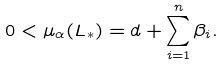Convert formula to latex. <formula><loc_0><loc_0><loc_500><loc_500>0 < \mu _ { \alpha } ( L _ { * } ) = d + \sum _ { i = 1 } ^ { n } \beta _ { i } .</formula> 